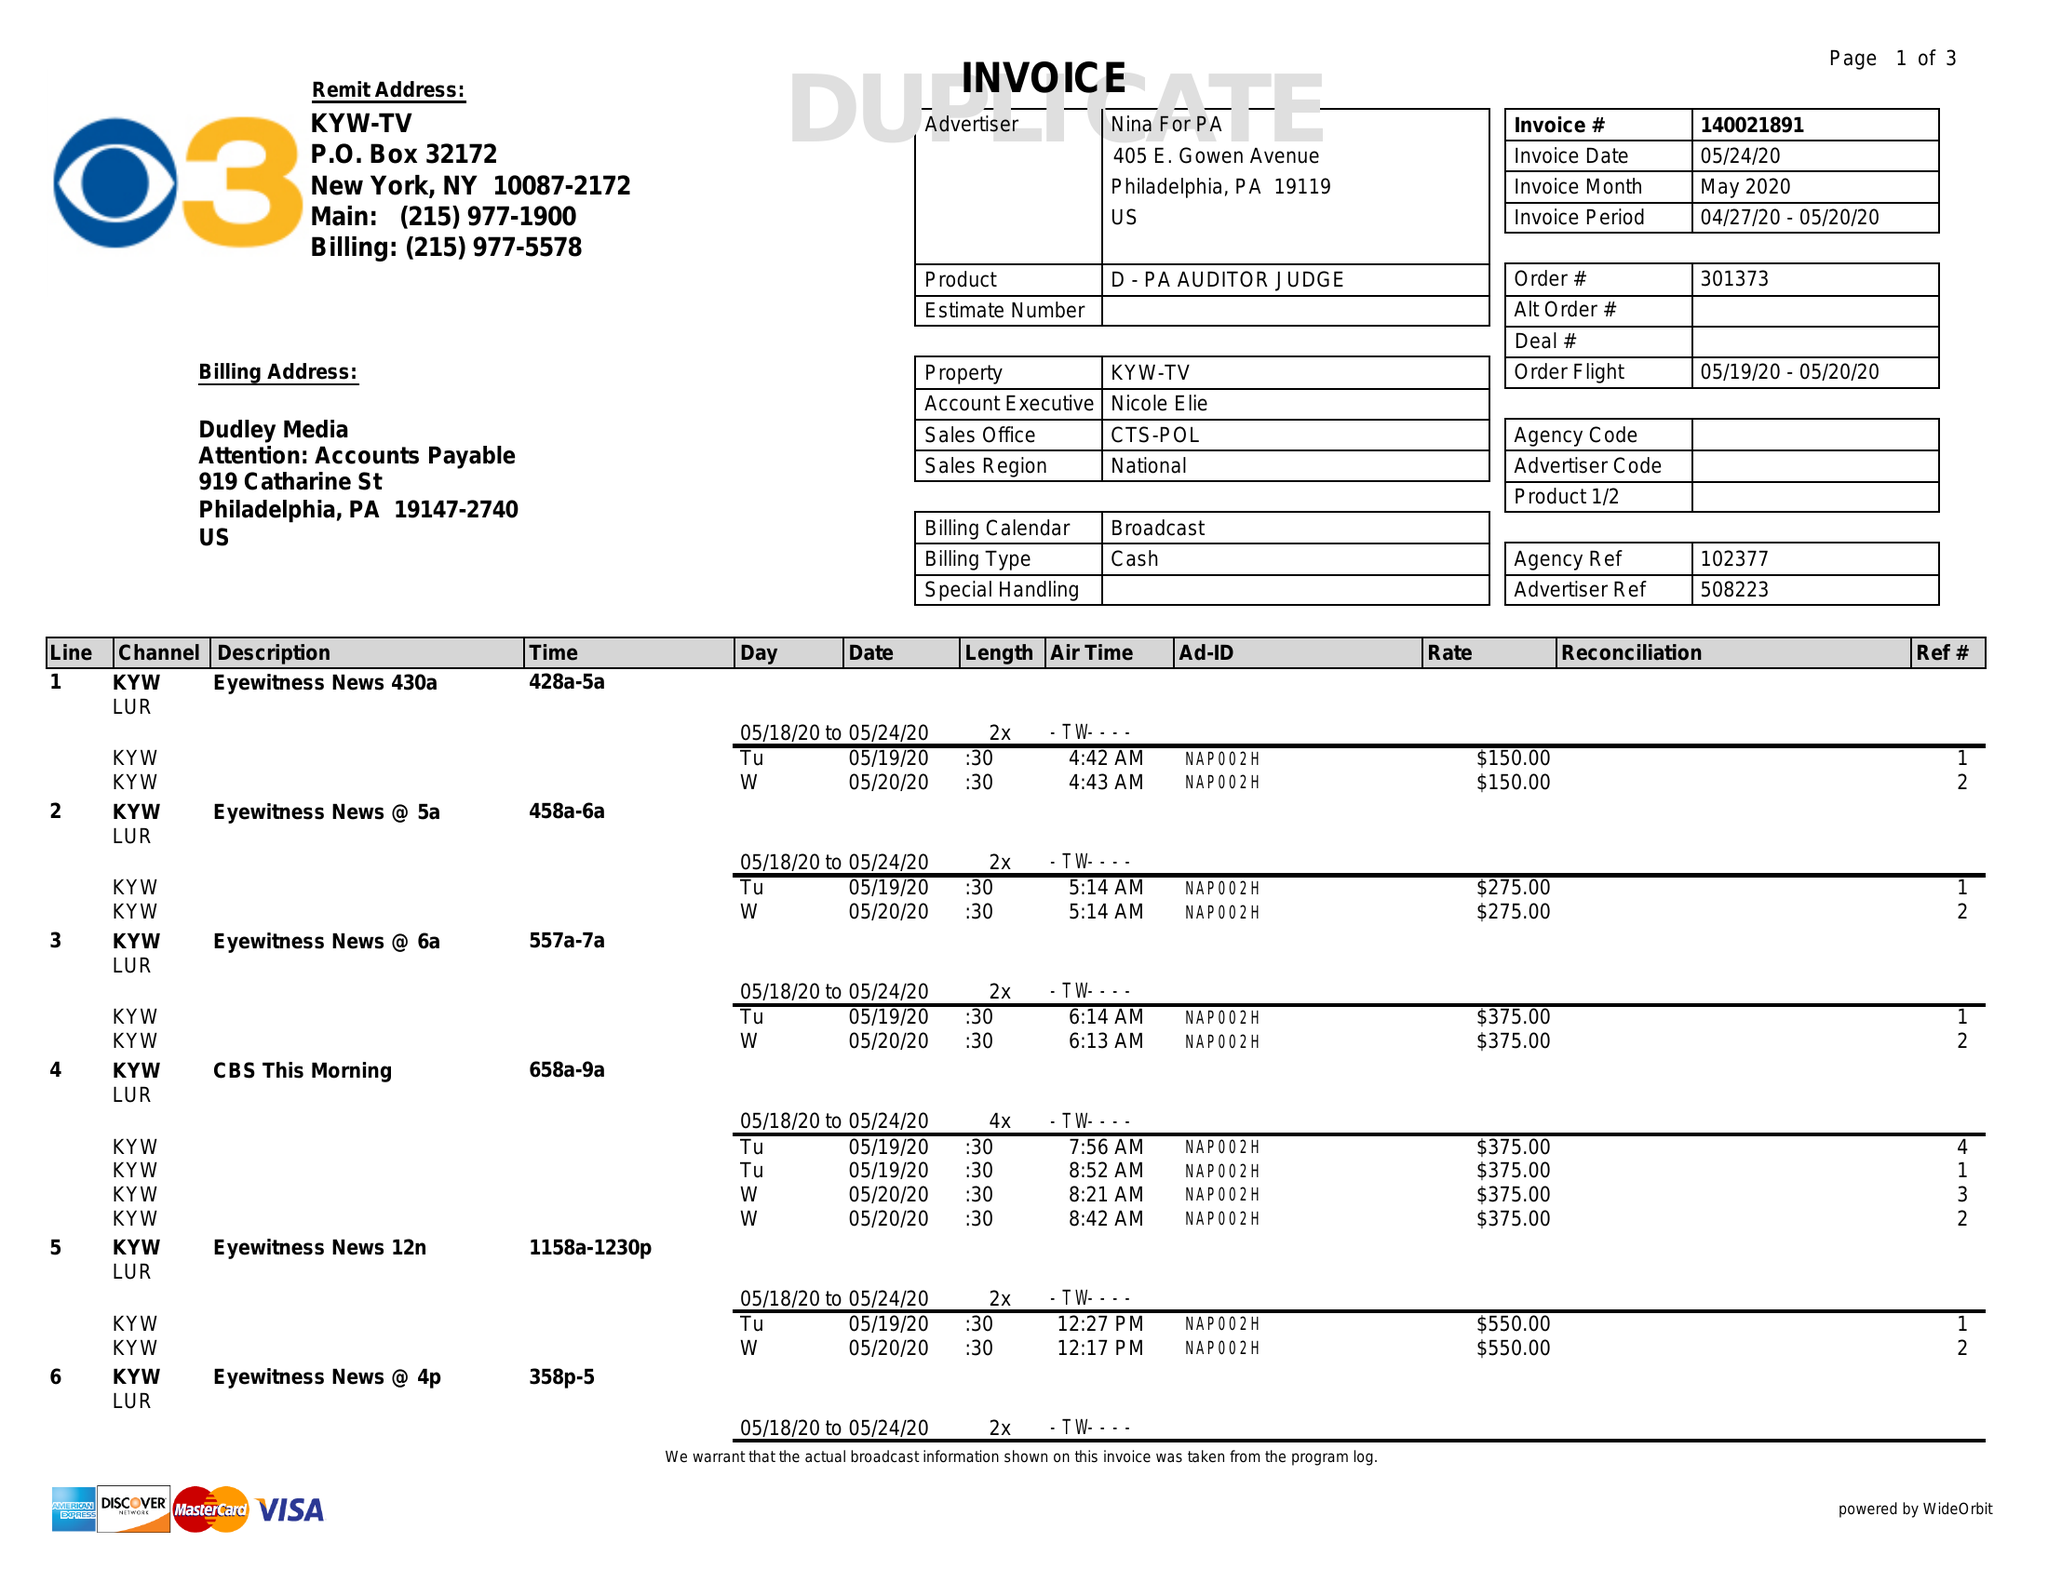What is the value for the gross_amount?
Answer the question using a single word or phrase. 12200.00 